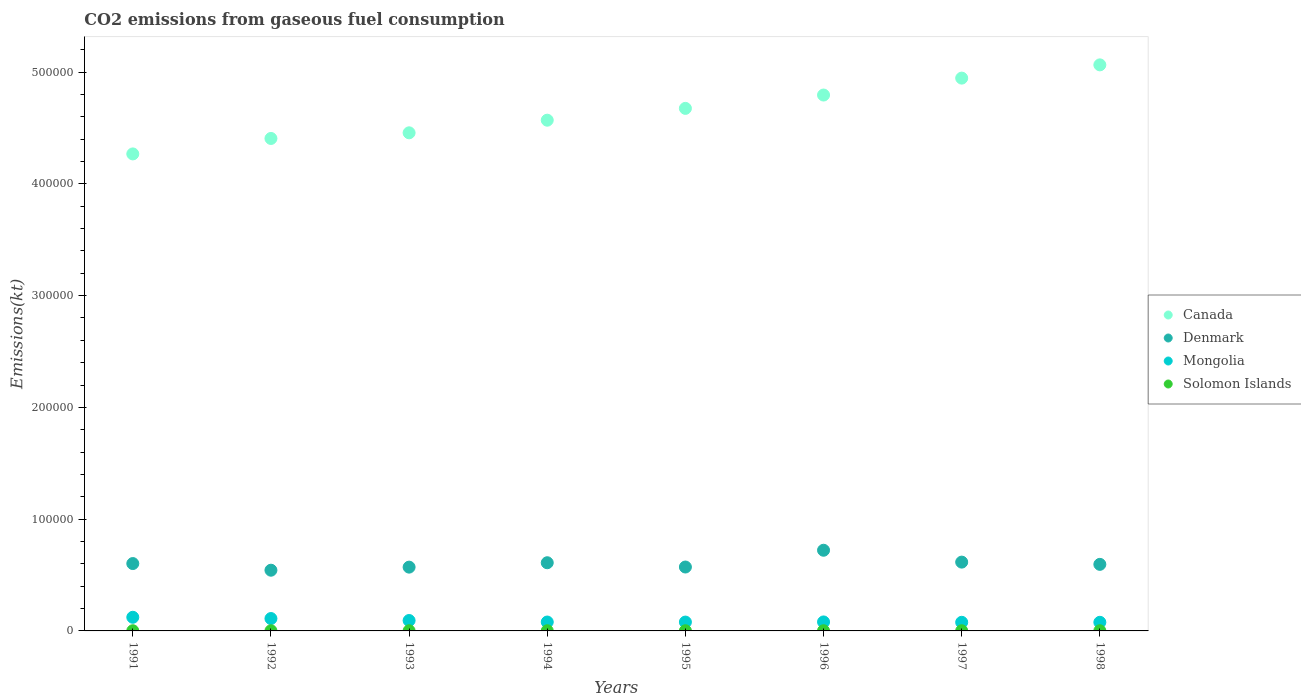What is the amount of CO2 emitted in Denmark in 1998?
Give a very brief answer. 5.96e+04. Across all years, what is the maximum amount of CO2 emitted in Solomon Islands?
Provide a short and direct response. 161.35. Across all years, what is the minimum amount of CO2 emitted in Canada?
Offer a terse response. 4.27e+05. In which year was the amount of CO2 emitted in Mongolia maximum?
Give a very brief answer. 1991. In which year was the amount of CO2 emitted in Solomon Islands minimum?
Your response must be concise. 1994. What is the total amount of CO2 emitted in Mongolia in the graph?
Ensure brevity in your answer.  7.19e+04. What is the difference between the amount of CO2 emitted in Canada in 1995 and that in 1998?
Keep it short and to the point. -3.89e+04. What is the difference between the amount of CO2 emitted in Denmark in 1998 and the amount of CO2 emitted in Mongolia in 1994?
Your response must be concise. 5.16e+04. What is the average amount of CO2 emitted in Denmark per year?
Provide a succinct answer. 6.04e+04. In the year 1997, what is the difference between the amount of CO2 emitted in Denmark and amount of CO2 emitted in Solomon Islands?
Your answer should be compact. 6.14e+04. In how many years, is the amount of CO2 emitted in Mongolia greater than 460000 kt?
Give a very brief answer. 0. What is the ratio of the amount of CO2 emitted in Canada in 1996 to that in 1997?
Your answer should be very brief. 0.97. Is the difference between the amount of CO2 emitted in Denmark in 1992 and 1996 greater than the difference between the amount of CO2 emitted in Solomon Islands in 1992 and 1996?
Offer a terse response. No. What is the difference between the highest and the lowest amount of CO2 emitted in Solomon Islands?
Your response must be concise. 7.33. In how many years, is the amount of CO2 emitted in Denmark greater than the average amount of CO2 emitted in Denmark taken over all years?
Offer a very short reply. 3. Is it the case that in every year, the sum of the amount of CO2 emitted in Denmark and amount of CO2 emitted in Solomon Islands  is greater than the sum of amount of CO2 emitted in Canada and amount of CO2 emitted in Mongolia?
Ensure brevity in your answer.  Yes. Is the amount of CO2 emitted in Denmark strictly greater than the amount of CO2 emitted in Canada over the years?
Provide a succinct answer. No. Is the amount of CO2 emitted in Canada strictly less than the amount of CO2 emitted in Denmark over the years?
Your answer should be very brief. No. How many dotlines are there?
Give a very brief answer. 4. Does the graph contain grids?
Make the answer very short. No. Where does the legend appear in the graph?
Ensure brevity in your answer.  Center right. How many legend labels are there?
Ensure brevity in your answer.  4. What is the title of the graph?
Offer a terse response. CO2 emissions from gaseous fuel consumption. Does "Czech Republic" appear as one of the legend labels in the graph?
Ensure brevity in your answer.  No. What is the label or title of the X-axis?
Your response must be concise. Years. What is the label or title of the Y-axis?
Provide a succinct answer. Emissions(kt). What is the Emissions(kt) of Canada in 1991?
Give a very brief answer. 4.27e+05. What is the Emissions(kt) in Denmark in 1991?
Provide a short and direct response. 6.03e+04. What is the Emissions(kt) of Mongolia in 1991?
Ensure brevity in your answer.  1.22e+04. What is the Emissions(kt) of Solomon Islands in 1991?
Offer a very short reply. 161.35. What is the Emissions(kt) of Canada in 1992?
Provide a succinct answer. 4.41e+05. What is the Emissions(kt) in Denmark in 1992?
Offer a very short reply. 5.43e+04. What is the Emissions(kt) in Mongolia in 1992?
Offer a very short reply. 1.11e+04. What is the Emissions(kt) in Solomon Islands in 1992?
Your answer should be very brief. 161.35. What is the Emissions(kt) in Canada in 1993?
Give a very brief answer. 4.46e+05. What is the Emissions(kt) of Denmark in 1993?
Make the answer very short. 5.71e+04. What is the Emissions(kt) of Mongolia in 1993?
Make the answer very short. 9314.18. What is the Emissions(kt) in Solomon Islands in 1993?
Give a very brief answer. 157.68. What is the Emissions(kt) in Canada in 1994?
Offer a very short reply. 4.57e+05. What is the Emissions(kt) of Denmark in 1994?
Ensure brevity in your answer.  6.10e+04. What is the Emissions(kt) of Mongolia in 1994?
Keep it short and to the point. 7961.06. What is the Emissions(kt) in Solomon Islands in 1994?
Ensure brevity in your answer.  154.01. What is the Emissions(kt) in Canada in 1995?
Your answer should be compact. 4.68e+05. What is the Emissions(kt) of Denmark in 1995?
Make the answer very short. 5.72e+04. What is the Emissions(kt) in Mongolia in 1995?
Offer a very short reply. 7924.39. What is the Emissions(kt) of Solomon Islands in 1995?
Ensure brevity in your answer.  161.35. What is the Emissions(kt) in Canada in 1996?
Keep it short and to the point. 4.79e+05. What is the Emissions(kt) in Denmark in 1996?
Your response must be concise. 7.22e+04. What is the Emissions(kt) in Mongolia in 1996?
Your response must be concise. 8041.73. What is the Emissions(kt) of Solomon Islands in 1996?
Give a very brief answer. 161.35. What is the Emissions(kt) of Canada in 1997?
Provide a short and direct response. 4.95e+05. What is the Emissions(kt) in Denmark in 1997?
Your answer should be very brief. 6.16e+04. What is the Emissions(kt) of Mongolia in 1997?
Ensure brevity in your answer.  7711.7. What is the Emissions(kt) of Solomon Islands in 1997?
Your answer should be very brief. 161.35. What is the Emissions(kt) of Canada in 1998?
Offer a terse response. 5.06e+05. What is the Emissions(kt) of Denmark in 1998?
Your answer should be compact. 5.96e+04. What is the Emissions(kt) of Mongolia in 1998?
Offer a terse response. 7708.03. What is the Emissions(kt) of Solomon Islands in 1998?
Offer a very short reply. 161.35. Across all years, what is the maximum Emissions(kt) of Canada?
Make the answer very short. 5.06e+05. Across all years, what is the maximum Emissions(kt) in Denmark?
Provide a short and direct response. 7.22e+04. Across all years, what is the maximum Emissions(kt) of Mongolia?
Offer a terse response. 1.22e+04. Across all years, what is the maximum Emissions(kt) in Solomon Islands?
Offer a very short reply. 161.35. Across all years, what is the minimum Emissions(kt) of Canada?
Ensure brevity in your answer.  4.27e+05. Across all years, what is the minimum Emissions(kt) in Denmark?
Your response must be concise. 5.43e+04. Across all years, what is the minimum Emissions(kt) of Mongolia?
Provide a short and direct response. 7708.03. Across all years, what is the minimum Emissions(kt) of Solomon Islands?
Your response must be concise. 154.01. What is the total Emissions(kt) of Canada in the graph?
Your answer should be compact. 3.72e+06. What is the total Emissions(kt) in Denmark in the graph?
Keep it short and to the point. 4.83e+05. What is the total Emissions(kt) of Mongolia in the graph?
Your answer should be very brief. 7.19e+04. What is the total Emissions(kt) in Solomon Islands in the graph?
Keep it short and to the point. 1279.78. What is the difference between the Emissions(kt) in Canada in 1991 and that in 1992?
Provide a succinct answer. -1.38e+04. What is the difference between the Emissions(kt) in Denmark in 1991 and that in 1992?
Give a very brief answer. 5947.87. What is the difference between the Emissions(kt) of Mongolia in 1991 and that in 1992?
Provide a succinct answer. 1129.44. What is the difference between the Emissions(kt) in Canada in 1991 and that in 1993?
Keep it short and to the point. -1.89e+04. What is the difference between the Emissions(kt) of Denmark in 1991 and that in 1993?
Keep it short and to the point. 3204.96. What is the difference between the Emissions(kt) in Mongolia in 1991 and that in 1993?
Provide a short and direct response. 2893.26. What is the difference between the Emissions(kt) of Solomon Islands in 1991 and that in 1993?
Your answer should be compact. 3.67. What is the difference between the Emissions(kt) of Canada in 1991 and that in 1994?
Provide a short and direct response. -3.02e+04. What is the difference between the Emissions(kt) of Denmark in 1991 and that in 1994?
Provide a short and direct response. -729.73. What is the difference between the Emissions(kt) in Mongolia in 1991 and that in 1994?
Ensure brevity in your answer.  4246.39. What is the difference between the Emissions(kt) of Solomon Islands in 1991 and that in 1994?
Your answer should be compact. 7.33. What is the difference between the Emissions(kt) in Canada in 1991 and that in 1995?
Your answer should be compact. -4.07e+04. What is the difference between the Emissions(kt) in Denmark in 1991 and that in 1995?
Provide a succinct answer. 3098.61. What is the difference between the Emissions(kt) of Mongolia in 1991 and that in 1995?
Your answer should be very brief. 4283.06. What is the difference between the Emissions(kt) in Solomon Islands in 1991 and that in 1995?
Your response must be concise. 0. What is the difference between the Emissions(kt) in Canada in 1991 and that in 1996?
Your answer should be compact. -5.27e+04. What is the difference between the Emissions(kt) of Denmark in 1991 and that in 1996?
Make the answer very short. -1.19e+04. What is the difference between the Emissions(kt) of Mongolia in 1991 and that in 1996?
Offer a very short reply. 4165.71. What is the difference between the Emissions(kt) in Solomon Islands in 1991 and that in 1996?
Provide a short and direct response. 0. What is the difference between the Emissions(kt) of Canada in 1991 and that in 1997?
Keep it short and to the point. -6.78e+04. What is the difference between the Emissions(kt) of Denmark in 1991 and that in 1997?
Your answer should be compact. -1287.12. What is the difference between the Emissions(kt) of Mongolia in 1991 and that in 1997?
Offer a very short reply. 4495.74. What is the difference between the Emissions(kt) of Solomon Islands in 1991 and that in 1997?
Your response must be concise. 0. What is the difference between the Emissions(kt) in Canada in 1991 and that in 1998?
Provide a succinct answer. -7.97e+04. What is the difference between the Emissions(kt) in Denmark in 1991 and that in 1998?
Offer a terse response. 718.73. What is the difference between the Emissions(kt) in Mongolia in 1991 and that in 1998?
Make the answer very short. 4499.41. What is the difference between the Emissions(kt) in Canada in 1992 and that in 1993?
Your answer should be compact. -5056.79. What is the difference between the Emissions(kt) of Denmark in 1992 and that in 1993?
Your answer should be very brief. -2742.92. What is the difference between the Emissions(kt) in Mongolia in 1992 and that in 1993?
Offer a very short reply. 1763.83. What is the difference between the Emissions(kt) of Solomon Islands in 1992 and that in 1993?
Give a very brief answer. 3.67. What is the difference between the Emissions(kt) of Canada in 1992 and that in 1994?
Your answer should be very brief. -1.63e+04. What is the difference between the Emissions(kt) in Denmark in 1992 and that in 1994?
Your answer should be compact. -6677.61. What is the difference between the Emissions(kt) in Mongolia in 1992 and that in 1994?
Make the answer very short. 3116.95. What is the difference between the Emissions(kt) in Solomon Islands in 1992 and that in 1994?
Ensure brevity in your answer.  7.33. What is the difference between the Emissions(kt) of Canada in 1992 and that in 1995?
Offer a very short reply. -2.69e+04. What is the difference between the Emissions(kt) of Denmark in 1992 and that in 1995?
Offer a terse response. -2849.26. What is the difference between the Emissions(kt) in Mongolia in 1992 and that in 1995?
Make the answer very short. 3153.62. What is the difference between the Emissions(kt) in Canada in 1992 and that in 1996?
Your answer should be very brief. -3.89e+04. What is the difference between the Emissions(kt) of Denmark in 1992 and that in 1996?
Your answer should be very brief. -1.79e+04. What is the difference between the Emissions(kt) of Mongolia in 1992 and that in 1996?
Offer a terse response. 3036.28. What is the difference between the Emissions(kt) of Canada in 1992 and that in 1997?
Provide a short and direct response. -5.40e+04. What is the difference between the Emissions(kt) of Denmark in 1992 and that in 1997?
Your response must be concise. -7234.99. What is the difference between the Emissions(kt) of Mongolia in 1992 and that in 1997?
Your response must be concise. 3366.31. What is the difference between the Emissions(kt) in Solomon Islands in 1992 and that in 1997?
Offer a terse response. 0. What is the difference between the Emissions(kt) of Canada in 1992 and that in 1998?
Make the answer very short. -6.58e+04. What is the difference between the Emissions(kt) in Denmark in 1992 and that in 1998?
Offer a very short reply. -5229.14. What is the difference between the Emissions(kt) of Mongolia in 1992 and that in 1998?
Make the answer very short. 3369.97. What is the difference between the Emissions(kt) of Canada in 1993 and that in 1994?
Keep it short and to the point. -1.13e+04. What is the difference between the Emissions(kt) in Denmark in 1993 and that in 1994?
Provide a short and direct response. -3934.69. What is the difference between the Emissions(kt) in Mongolia in 1993 and that in 1994?
Keep it short and to the point. 1353.12. What is the difference between the Emissions(kt) of Solomon Islands in 1993 and that in 1994?
Your answer should be very brief. 3.67. What is the difference between the Emissions(kt) of Canada in 1993 and that in 1995?
Your answer should be very brief. -2.19e+04. What is the difference between the Emissions(kt) in Denmark in 1993 and that in 1995?
Your answer should be very brief. -106.34. What is the difference between the Emissions(kt) of Mongolia in 1993 and that in 1995?
Provide a succinct answer. 1389.79. What is the difference between the Emissions(kt) in Solomon Islands in 1993 and that in 1995?
Give a very brief answer. -3.67. What is the difference between the Emissions(kt) of Canada in 1993 and that in 1996?
Offer a very short reply. -3.38e+04. What is the difference between the Emissions(kt) in Denmark in 1993 and that in 1996?
Your answer should be compact. -1.51e+04. What is the difference between the Emissions(kt) of Mongolia in 1993 and that in 1996?
Keep it short and to the point. 1272.45. What is the difference between the Emissions(kt) of Solomon Islands in 1993 and that in 1996?
Give a very brief answer. -3.67. What is the difference between the Emissions(kt) in Canada in 1993 and that in 1997?
Ensure brevity in your answer.  -4.89e+04. What is the difference between the Emissions(kt) of Denmark in 1993 and that in 1997?
Offer a terse response. -4492.07. What is the difference between the Emissions(kt) in Mongolia in 1993 and that in 1997?
Offer a very short reply. 1602.48. What is the difference between the Emissions(kt) of Solomon Islands in 1993 and that in 1997?
Provide a succinct answer. -3.67. What is the difference between the Emissions(kt) in Canada in 1993 and that in 1998?
Your answer should be compact. -6.08e+04. What is the difference between the Emissions(kt) in Denmark in 1993 and that in 1998?
Provide a short and direct response. -2486.23. What is the difference between the Emissions(kt) of Mongolia in 1993 and that in 1998?
Give a very brief answer. 1606.15. What is the difference between the Emissions(kt) of Solomon Islands in 1993 and that in 1998?
Provide a short and direct response. -3.67. What is the difference between the Emissions(kt) of Canada in 1994 and that in 1995?
Your response must be concise. -1.06e+04. What is the difference between the Emissions(kt) in Denmark in 1994 and that in 1995?
Your answer should be very brief. 3828.35. What is the difference between the Emissions(kt) of Mongolia in 1994 and that in 1995?
Your answer should be very brief. 36.67. What is the difference between the Emissions(kt) in Solomon Islands in 1994 and that in 1995?
Provide a short and direct response. -7.33. What is the difference between the Emissions(kt) of Canada in 1994 and that in 1996?
Keep it short and to the point. -2.25e+04. What is the difference between the Emissions(kt) in Denmark in 1994 and that in 1996?
Make the answer very short. -1.12e+04. What is the difference between the Emissions(kt) in Mongolia in 1994 and that in 1996?
Provide a succinct answer. -80.67. What is the difference between the Emissions(kt) of Solomon Islands in 1994 and that in 1996?
Provide a short and direct response. -7.33. What is the difference between the Emissions(kt) in Canada in 1994 and that in 1997?
Give a very brief answer. -3.76e+04. What is the difference between the Emissions(kt) in Denmark in 1994 and that in 1997?
Ensure brevity in your answer.  -557.38. What is the difference between the Emissions(kt) of Mongolia in 1994 and that in 1997?
Your answer should be very brief. 249.36. What is the difference between the Emissions(kt) of Solomon Islands in 1994 and that in 1997?
Ensure brevity in your answer.  -7.33. What is the difference between the Emissions(kt) of Canada in 1994 and that in 1998?
Your response must be concise. -4.95e+04. What is the difference between the Emissions(kt) of Denmark in 1994 and that in 1998?
Give a very brief answer. 1448.46. What is the difference between the Emissions(kt) of Mongolia in 1994 and that in 1998?
Make the answer very short. 253.02. What is the difference between the Emissions(kt) of Solomon Islands in 1994 and that in 1998?
Give a very brief answer. -7.33. What is the difference between the Emissions(kt) of Canada in 1995 and that in 1996?
Make the answer very short. -1.19e+04. What is the difference between the Emissions(kt) in Denmark in 1995 and that in 1996?
Ensure brevity in your answer.  -1.50e+04. What is the difference between the Emissions(kt) in Mongolia in 1995 and that in 1996?
Provide a short and direct response. -117.34. What is the difference between the Emissions(kt) in Solomon Islands in 1995 and that in 1996?
Provide a succinct answer. 0. What is the difference between the Emissions(kt) of Canada in 1995 and that in 1997?
Offer a terse response. -2.71e+04. What is the difference between the Emissions(kt) of Denmark in 1995 and that in 1997?
Provide a short and direct response. -4385.73. What is the difference between the Emissions(kt) of Mongolia in 1995 and that in 1997?
Your answer should be very brief. 212.69. What is the difference between the Emissions(kt) in Canada in 1995 and that in 1998?
Provide a short and direct response. -3.89e+04. What is the difference between the Emissions(kt) in Denmark in 1995 and that in 1998?
Provide a succinct answer. -2379.88. What is the difference between the Emissions(kt) in Mongolia in 1995 and that in 1998?
Keep it short and to the point. 216.35. What is the difference between the Emissions(kt) of Canada in 1996 and that in 1997?
Your response must be concise. -1.51e+04. What is the difference between the Emissions(kt) of Denmark in 1996 and that in 1997?
Ensure brevity in your answer.  1.06e+04. What is the difference between the Emissions(kt) of Mongolia in 1996 and that in 1997?
Provide a short and direct response. 330.03. What is the difference between the Emissions(kt) of Canada in 1996 and that in 1998?
Your answer should be compact. -2.70e+04. What is the difference between the Emissions(kt) of Denmark in 1996 and that in 1998?
Ensure brevity in your answer.  1.26e+04. What is the difference between the Emissions(kt) in Mongolia in 1996 and that in 1998?
Ensure brevity in your answer.  333.7. What is the difference between the Emissions(kt) in Solomon Islands in 1996 and that in 1998?
Offer a very short reply. 0. What is the difference between the Emissions(kt) of Canada in 1997 and that in 1998?
Keep it short and to the point. -1.19e+04. What is the difference between the Emissions(kt) in Denmark in 1997 and that in 1998?
Provide a short and direct response. 2005.85. What is the difference between the Emissions(kt) of Mongolia in 1997 and that in 1998?
Keep it short and to the point. 3.67. What is the difference between the Emissions(kt) in Solomon Islands in 1997 and that in 1998?
Offer a very short reply. 0. What is the difference between the Emissions(kt) in Canada in 1991 and the Emissions(kt) in Denmark in 1992?
Ensure brevity in your answer.  3.72e+05. What is the difference between the Emissions(kt) in Canada in 1991 and the Emissions(kt) in Mongolia in 1992?
Give a very brief answer. 4.16e+05. What is the difference between the Emissions(kt) of Canada in 1991 and the Emissions(kt) of Solomon Islands in 1992?
Your answer should be compact. 4.27e+05. What is the difference between the Emissions(kt) in Denmark in 1991 and the Emissions(kt) in Mongolia in 1992?
Provide a succinct answer. 4.92e+04. What is the difference between the Emissions(kt) in Denmark in 1991 and the Emissions(kt) in Solomon Islands in 1992?
Your answer should be compact. 6.01e+04. What is the difference between the Emissions(kt) of Mongolia in 1991 and the Emissions(kt) of Solomon Islands in 1992?
Provide a succinct answer. 1.20e+04. What is the difference between the Emissions(kt) of Canada in 1991 and the Emissions(kt) of Denmark in 1993?
Ensure brevity in your answer.  3.70e+05. What is the difference between the Emissions(kt) of Canada in 1991 and the Emissions(kt) of Mongolia in 1993?
Your response must be concise. 4.17e+05. What is the difference between the Emissions(kt) in Canada in 1991 and the Emissions(kt) in Solomon Islands in 1993?
Provide a succinct answer. 4.27e+05. What is the difference between the Emissions(kt) of Denmark in 1991 and the Emissions(kt) of Mongolia in 1993?
Offer a terse response. 5.10e+04. What is the difference between the Emissions(kt) of Denmark in 1991 and the Emissions(kt) of Solomon Islands in 1993?
Your answer should be very brief. 6.01e+04. What is the difference between the Emissions(kt) of Mongolia in 1991 and the Emissions(kt) of Solomon Islands in 1993?
Offer a very short reply. 1.20e+04. What is the difference between the Emissions(kt) in Canada in 1991 and the Emissions(kt) in Denmark in 1994?
Your answer should be compact. 3.66e+05. What is the difference between the Emissions(kt) of Canada in 1991 and the Emissions(kt) of Mongolia in 1994?
Offer a terse response. 4.19e+05. What is the difference between the Emissions(kt) in Canada in 1991 and the Emissions(kt) in Solomon Islands in 1994?
Offer a very short reply. 4.27e+05. What is the difference between the Emissions(kt) of Denmark in 1991 and the Emissions(kt) of Mongolia in 1994?
Your answer should be very brief. 5.23e+04. What is the difference between the Emissions(kt) of Denmark in 1991 and the Emissions(kt) of Solomon Islands in 1994?
Your response must be concise. 6.01e+04. What is the difference between the Emissions(kt) in Mongolia in 1991 and the Emissions(kt) in Solomon Islands in 1994?
Provide a short and direct response. 1.21e+04. What is the difference between the Emissions(kt) in Canada in 1991 and the Emissions(kt) in Denmark in 1995?
Offer a terse response. 3.70e+05. What is the difference between the Emissions(kt) of Canada in 1991 and the Emissions(kt) of Mongolia in 1995?
Your answer should be compact. 4.19e+05. What is the difference between the Emissions(kt) in Canada in 1991 and the Emissions(kt) in Solomon Islands in 1995?
Give a very brief answer. 4.27e+05. What is the difference between the Emissions(kt) in Denmark in 1991 and the Emissions(kt) in Mongolia in 1995?
Your response must be concise. 5.23e+04. What is the difference between the Emissions(kt) of Denmark in 1991 and the Emissions(kt) of Solomon Islands in 1995?
Provide a short and direct response. 6.01e+04. What is the difference between the Emissions(kt) of Mongolia in 1991 and the Emissions(kt) of Solomon Islands in 1995?
Provide a succinct answer. 1.20e+04. What is the difference between the Emissions(kt) in Canada in 1991 and the Emissions(kt) in Denmark in 1996?
Offer a very short reply. 3.55e+05. What is the difference between the Emissions(kt) in Canada in 1991 and the Emissions(kt) in Mongolia in 1996?
Make the answer very short. 4.19e+05. What is the difference between the Emissions(kt) of Canada in 1991 and the Emissions(kt) of Solomon Islands in 1996?
Keep it short and to the point. 4.27e+05. What is the difference between the Emissions(kt) in Denmark in 1991 and the Emissions(kt) in Mongolia in 1996?
Make the answer very short. 5.22e+04. What is the difference between the Emissions(kt) in Denmark in 1991 and the Emissions(kt) in Solomon Islands in 1996?
Keep it short and to the point. 6.01e+04. What is the difference between the Emissions(kt) of Mongolia in 1991 and the Emissions(kt) of Solomon Islands in 1996?
Offer a very short reply. 1.20e+04. What is the difference between the Emissions(kt) in Canada in 1991 and the Emissions(kt) in Denmark in 1997?
Your response must be concise. 3.65e+05. What is the difference between the Emissions(kt) in Canada in 1991 and the Emissions(kt) in Mongolia in 1997?
Offer a very short reply. 4.19e+05. What is the difference between the Emissions(kt) in Canada in 1991 and the Emissions(kt) in Solomon Islands in 1997?
Your response must be concise. 4.27e+05. What is the difference between the Emissions(kt) in Denmark in 1991 and the Emissions(kt) in Mongolia in 1997?
Offer a terse response. 5.26e+04. What is the difference between the Emissions(kt) of Denmark in 1991 and the Emissions(kt) of Solomon Islands in 1997?
Ensure brevity in your answer.  6.01e+04. What is the difference between the Emissions(kt) of Mongolia in 1991 and the Emissions(kt) of Solomon Islands in 1997?
Ensure brevity in your answer.  1.20e+04. What is the difference between the Emissions(kt) of Canada in 1991 and the Emissions(kt) of Denmark in 1998?
Make the answer very short. 3.67e+05. What is the difference between the Emissions(kt) of Canada in 1991 and the Emissions(kt) of Mongolia in 1998?
Your answer should be very brief. 4.19e+05. What is the difference between the Emissions(kt) of Canada in 1991 and the Emissions(kt) of Solomon Islands in 1998?
Provide a short and direct response. 4.27e+05. What is the difference between the Emissions(kt) of Denmark in 1991 and the Emissions(kt) of Mongolia in 1998?
Ensure brevity in your answer.  5.26e+04. What is the difference between the Emissions(kt) of Denmark in 1991 and the Emissions(kt) of Solomon Islands in 1998?
Ensure brevity in your answer.  6.01e+04. What is the difference between the Emissions(kt) in Mongolia in 1991 and the Emissions(kt) in Solomon Islands in 1998?
Provide a succinct answer. 1.20e+04. What is the difference between the Emissions(kt) of Canada in 1992 and the Emissions(kt) of Denmark in 1993?
Ensure brevity in your answer.  3.84e+05. What is the difference between the Emissions(kt) in Canada in 1992 and the Emissions(kt) in Mongolia in 1993?
Offer a terse response. 4.31e+05. What is the difference between the Emissions(kt) of Canada in 1992 and the Emissions(kt) of Solomon Islands in 1993?
Provide a succinct answer. 4.40e+05. What is the difference between the Emissions(kt) in Denmark in 1992 and the Emissions(kt) in Mongolia in 1993?
Give a very brief answer. 4.50e+04. What is the difference between the Emissions(kt) of Denmark in 1992 and the Emissions(kt) of Solomon Islands in 1993?
Make the answer very short. 5.42e+04. What is the difference between the Emissions(kt) in Mongolia in 1992 and the Emissions(kt) in Solomon Islands in 1993?
Provide a succinct answer. 1.09e+04. What is the difference between the Emissions(kt) in Canada in 1992 and the Emissions(kt) in Denmark in 1994?
Your answer should be compact. 3.80e+05. What is the difference between the Emissions(kt) of Canada in 1992 and the Emissions(kt) of Mongolia in 1994?
Your answer should be compact. 4.33e+05. What is the difference between the Emissions(kt) in Canada in 1992 and the Emissions(kt) in Solomon Islands in 1994?
Provide a succinct answer. 4.40e+05. What is the difference between the Emissions(kt) of Denmark in 1992 and the Emissions(kt) of Mongolia in 1994?
Provide a short and direct response. 4.64e+04. What is the difference between the Emissions(kt) in Denmark in 1992 and the Emissions(kt) in Solomon Islands in 1994?
Give a very brief answer. 5.42e+04. What is the difference between the Emissions(kt) in Mongolia in 1992 and the Emissions(kt) in Solomon Islands in 1994?
Provide a short and direct response. 1.09e+04. What is the difference between the Emissions(kt) of Canada in 1992 and the Emissions(kt) of Denmark in 1995?
Your answer should be very brief. 3.83e+05. What is the difference between the Emissions(kt) in Canada in 1992 and the Emissions(kt) in Mongolia in 1995?
Your answer should be compact. 4.33e+05. What is the difference between the Emissions(kt) of Canada in 1992 and the Emissions(kt) of Solomon Islands in 1995?
Your answer should be very brief. 4.40e+05. What is the difference between the Emissions(kt) of Denmark in 1992 and the Emissions(kt) of Mongolia in 1995?
Provide a succinct answer. 4.64e+04. What is the difference between the Emissions(kt) of Denmark in 1992 and the Emissions(kt) of Solomon Islands in 1995?
Your answer should be very brief. 5.42e+04. What is the difference between the Emissions(kt) of Mongolia in 1992 and the Emissions(kt) of Solomon Islands in 1995?
Give a very brief answer. 1.09e+04. What is the difference between the Emissions(kt) of Canada in 1992 and the Emissions(kt) of Denmark in 1996?
Offer a terse response. 3.68e+05. What is the difference between the Emissions(kt) in Canada in 1992 and the Emissions(kt) in Mongolia in 1996?
Your answer should be very brief. 4.33e+05. What is the difference between the Emissions(kt) in Canada in 1992 and the Emissions(kt) in Solomon Islands in 1996?
Offer a very short reply. 4.40e+05. What is the difference between the Emissions(kt) in Denmark in 1992 and the Emissions(kt) in Mongolia in 1996?
Offer a very short reply. 4.63e+04. What is the difference between the Emissions(kt) of Denmark in 1992 and the Emissions(kt) of Solomon Islands in 1996?
Keep it short and to the point. 5.42e+04. What is the difference between the Emissions(kt) of Mongolia in 1992 and the Emissions(kt) of Solomon Islands in 1996?
Ensure brevity in your answer.  1.09e+04. What is the difference between the Emissions(kt) in Canada in 1992 and the Emissions(kt) in Denmark in 1997?
Give a very brief answer. 3.79e+05. What is the difference between the Emissions(kt) in Canada in 1992 and the Emissions(kt) in Mongolia in 1997?
Offer a terse response. 4.33e+05. What is the difference between the Emissions(kt) of Canada in 1992 and the Emissions(kt) of Solomon Islands in 1997?
Ensure brevity in your answer.  4.40e+05. What is the difference between the Emissions(kt) of Denmark in 1992 and the Emissions(kt) of Mongolia in 1997?
Your answer should be very brief. 4.66e+04. What is the difference between the Emissions(kt) in Denmark in 1992 and the Emissions(kt) in Solomon Islands in 1997?
Offer a very short reply. 5.42e+04. What is the difference between the Emissions(kt) of Mongolia in 1992 and the Emissions(kt) of Solomon Islands in 1997?
Offer a terse response. 1.09e+04. What is the difference between the Emissions(kt) of Canada in 1992 and the Emissions(kt) of Denmark in 1998?
Keep it short and to the point. 3.81e+05. What is the difference between the Emissions(kt) of Canada in 1992 and the Emissions(kt) of Mongolia in 1998?
Your answer should be compact. 4.33e+05. What is the difference between the Emissions(kt) in Canada in 1992 and the Emissions(kt) in Solomon Islands in 1998?
Give a very brief answer. 4.40e+05. What is the difference between the Emissions(kt) of Denmark in 1992 and the Emissions(kt) of Mongolia in 1998?
Your answer should be very brief. 4.66e+04. What is the difference between the Emissions(kt) of Denmark in 1992 and the Emissions(kt) of Solomon Islands in 1998?
Keep it short and to the point. 5.42e+04. What is the difference between the Emissions(kt) of Mongolia in 1992 and the Emissions(kt) of Solomon Islands in 1998?
Offer a very short reply. 1.09e+04. What is the difference between the Emissions(kt) of Canada in 1993 and the Emissions(kt) of Denmark in 1994?
Make the answer very short. 3.85e+05. What is the difference between the Emissions(kt) in Canada in 1993 and the Emissions(kt) in Mongolia in 1994?
Make the answer very short. 4.38e+05. What is the difference between the Emissions(kt) in Canada in 1993 and the Emissions(kt) in Solomon Islands in 1994?
Ensure brevity in your answer.  4.46e+05. What is the difference between the Emissions(kt) of Denmark in 1993 and the Emissions(kt) of Mongolia in 1994?
Offer a terse response. 4.91e+04. What is the difference between the Emissions(kt) of Denmark in 1993 and the Emissions(kt) of Solomon Islands in 1994?
Provide a short and direct response. 5.69e+04. What is the difference between the Emissions(kt) in Mongolia in 1993 and the Emissions(kt) in Solomon Islands in 1994?
Provide a short and direct response. 9160.17. What is the difference between the Emissions(kt) in Canada in 1993 and the Emissions(kt) in Denmark in 1995?
Give a very brief answer. 3.88e+05. What is the difference between the Emissions(kt) in Canada in 1993 and the Emissions(kt) in Mongolia in 1995?
Your response must be concise. 4.38e+05. What is the difference between the Emissions(kt) in Canada in 1993 and the Emissions(kt) in Solomon Islands in 1995?
Offer a terse response. 4.46e+05. What is the difference between the Emissions(kt) of Denmark in 1993 and the Emissions(kt) of Mongolia in 1995?
Give a very brief answer. 4.91e+04. What is the difference between the Emissions(kt) of Denmark in 1993 and the Emissions(kt) of Solomon Islands in 1995?
Offer a very short reply. 5.69e+04. What is the difference between the Emissions(kt) in Mongolia in 1993 and the Emissions(kt) in Solomon Islands in 1995?
Offer a very short reply. 9152.83. What is the difference between the Emissions(kt) of Canada in 1993 and the Emissions(kt) of Denmark in 1996?
Keep it short and to the point. 3.73e+05. What is the difference between the Emissions(kt) of Canada in 1993 and the Emissions(kt) of Mongolia in 1996?
Your answer should be compact. 4.38e+05. What is the difference between the Emissions(kt) of Canada in 1993 and the Emissions(kt) of Solomon Islands in 1996?
Make the answer very short. 4.46e+05. What is the difference between the Emissions(kt) of Denmark in 1993 and the Emissions(kt) of Mongolia in 1996?
Your answer should be compact. 4.90e+04. What is the difference between the Emissions(kt) of Denmark in 1993 and the Emissions(kt) of Solomon Islands in 1996?
Provide a succinct answer. 5.69e+04. What is the difference between the Emissions(kt) in Mongolia in 1993 and the Emissions(kt) in Solomon Islands in 1996?
Provide a succinct answer. 9152.83. What is the difference between the Emissions(kt) in Canada in 1993 and the Emissions(kt) in Denmark in 1997?
Your answer should be compact. 3.84e+05. What is the difference between the Emissions(kt) in Canada in 1993 and the Emissions(kt) in Mongolia in 1997?
Offer a very short reply. 4.38e+05. What is the difference between the Emissions(kt) in Canada in 1993 and the Emissions(kt) in Solomon Islands in 1997?
Give a very brief answer. 4.46e+05. What is the difference between the Emissions(kt) of Denmark in 1993 and the Emissions(kt) of Mongolia in 1997?
Give a very brief answer. 4.94e+04. What is the difference between the Emissions(kt) of Denmark in 1993 and the Emissions(kt) of Solomon Islands in 1997?
Give a very brief answer. 5.69e+04. What is the difference between the Emissions(kt) of Mongolia in 1993 and the Emissions(kt) of Solomon Islands in 1997?
Keep it short and to the point. 9152.83. What is the difference between the Emissions(kt) in Canada in 1993 and the Emissions(kt) in Denmark in 1998?
Offer a very short reply. 3.86e+05. What is the difference between the Emissions(kt) in Canada in 1993 and the Emissions(kt) in Mongolia in 1998?
Your answer should be very brief. 4.38e+05. What is the difference between the Emissions(kt) of Canada in 1993 and the Emissions(kt) of Solomon Islands in 1998?
Give a very brief answer. 4.46e+05. What is the difference between the Emissions(kt) of Denmark in 1993 and the Emissions(kt) of Mongolia in 1998?
Offer a very short reply. 4.94e+04. What is the difference between the Emissions(kt) in Denmark in 1993 and the Emissions(kt) in Solomon Islands in 1998?
Give a very brief answer. 5.69e+04. What is the difference between the Emissions(kt) of Mongolia in 1993 and the Emissions(kt) of Solomon Islands in 1998?
Offer a terse response. 9152.83. What is the difference between the Emissions(kt) of Canada in 1994 and the Emissions(kt) of Denmark in 1995?
Offer a terse response. 4.00e+05. What is the difference between the Emissions(kt) in Canada in 1994 and the Emissions(kt) in Mongolia in 1995?
Your response must be concise. 4.49e+05. What is the difference between the Emissions(kt) of Canada in 1994 and the Emissions(kt) of Solomon Islands in 1995?
Your answer should be compact. 4.57e+05. What is the difference between the Emissions(kt) in Denmark in 1994 and the Emissions(kt) in Mongolia in 1995?
Your response must be concise. 5.31e+04. What is the difference between the Emissions(kt) in Denmark in 1994 and the Emissions(kt) in Solomon Islands in 1995?
Your answer should be compact. 6.08e+04. What is the difference between the Emissions(kt) in Mongolia in 1994 and the Emissions(kt) in Solomon Islands in 1995?
Your answer should be very brief. 7799.71. What is the difference between the Emissions(kt) in Canada in 1994 and the Emissions(kt) in Denmark in 1996?
Offer a very short reply. 3.85e+05. What is the difference between the Emissions(kt) of Canada in 1994 and the Emissions(kt) of Mongolia in 1996?
Provide a succinct answer. 4.49e+05. What is the difference between the Emissions(kt) in Canada in 1994 and the Emissions(kt) in Solomon Islands in 1996?
Offer a terse response. 4.57e+05. What is the difference between the Emissions(kt) in Denmark in 1994 and the Emissions(kt) in Mongolia in 1996?
Ensure brevity in your answer.  5.30e+04. What is the difference between the Emissions(kt) in Denmark in 1994 and the Emissions(kt) in Solomon Islands in 1996?
Offer a very short reply. 6.08e+04. What is the difference between the Emissions(kt) of Mongolia in 1994 and the Emissions(kt) of Solomon Islands in 1996?
Keep it short and to the point. 7799.71. What is the difference between the Emissions(kt) in Canada in 1994 and the Emissions(kt) in Denmark in 1997?
Provide a short and direct response. 3.95e+05. What is the difference between the Emissions(kt) of Canada in 1994 and the Emissions(kt) of Mongolia in 1997?
Ensure brevity in your answer.  4.49e+05. What is the difference between the Emissions(kt) in Canada in 1994 and the Emissions(kt) in Solomon Islands in 1997?
Keep it short and to the point. 4.57e+05. What is the difference between the Emissions(kt) in Denmark in 1994 and the Emissions(kt) in Mongolia in 1997?
Your response must be concise. 5.33e+04. What is the difference between the Emissions(kt) of Denmark in 1994 and the Emissions(kt) of Solomon Islands in 1997?
Your response must be concise. 6.08e+04. What is the difference between the Emissions(kt) of Mongolia in 1994 and the Emissions(kt) of Solomon Islands in 1997?
Provide a short and direct response. 7799.71. What is the difference between the Emissions(kt) in Canada in 1994 and the Emissions(kt) in Denmark in 1998?
Your response must be concise. 3.97e+05. What is the difference between the Emissions(kt) in Canada in 1994 and the Emissions(kt) in Mongolia in 1998?
Your answer should be compact. 4.49e+05. What is the difference between the Emissions(kt) in Canada in 1994 and the Emissions(kt) in Solomon Islands in 1998?
Your answer should be very brief. 4.57e+05. What is the difference between the Emissions(kt) in Denmark in 1994 and the Emissions(kt) in Mongolia in 1998?
Your response must be concise. 5.33e+04. What is the difference between the Emissions(kt) in Denmark in 1994 and the Emissions(kt) in Solomon Islands in 1998?
Give a very brief answer. 6.08e+04. What is the difference between the Emissions(kt) of Mongolia in 1994 and the Emissions(kt) of Solomon Islands in 1998?
Your answer should be compact. 7799.71. What is the difference between the Emissions(kt) in Canada in 1995 and the Emissions(kt) in Denmark in 1996?
Keep it short and to the point. 3.95e+05. What is the difference between the Emissions(kt) in Canada in 1995 and the Emissions(kt) in Mongolia in 1996?
Offer a terse response. 4.59e+05. What is the difference between the Emissions(kt) in Canada in 1995 and the Emissions(kt) in Solomon Islands in 1996?
Offer a terse response. 4.67e+05. What is the difference between the Emissions(kt) of Denmark in 1995 and the Emissions(kt) of Mongolia in 1996?
Your answer should be compact. 4.91e+04. What is the difference between the Emissions(kt) of Denmark in 1995 and the Emissions(kt) of Solomon Islands in 1996?
Offer a terse response. 5.70e+04. What is the difference between the Emissions(kt) of Mongolia in 1995 and the Emissions(kt) of Solomon Islands in 1996?
Your response must be concise. 7763.04. What is the difference between the Emissions(kt) in Canada in 1995 and the Emissions(kt) in Denmark in 1997?
Offer a very short reply. 4.06e+05. What is the difference between the Emissions(kt) of Canada in 1995 and the Emissions(kt) of Mongolia in 1997?
Your answer should be compact. 4.60e+05. What is the difference between the Emissions(kt) in Canada in 1995 and the Emissions(kt) in Solomon Islands in 1997?
Your answer should be very brief. 4.67e+05. What is the difference between the Emissions(kt) in Denmark in 1995 and the Emissions(kt) in Mongolia in 1997?
Offer a terse response. 4.95e+04. What is the difference between the Emissions(kt) in Denmark in 1995 and the Emissions(kt) in Solomon Islands in 1997?
Keep it short and to the point. 5.70e+04. What is the difference between the Emissions(kt) in Mongolia in 1995 and the Emissions(kt) in Solomon Islands in 1997?
Your response must be concise. 7763.04. What is the difference between the Emissions(kt) of Canada in 1995 and the Emissions(kt) of Denmark in 1998?
Make the answer very short. 4.08e+05. What is the difference between the Emissions(kt) in Canada in 1995 and the Emissions(kt) in Mongolia in 1998?
Your answer should be compact. 4.60e+05. What is the difference between the Emissions(kt) in Canada in 1995 and the Emissions(kt) in Solomon Islands in 1998?
Provide a short and direct response. 4.67e+05. What is the difference between the Emissions(kt) of Denmark in 1995 and the Emissions(kt) of Mongolia in 1998?
Ensure brevity in your answer.  4.95e+04. What is the difference between the Emissions(kt) of Denmark in 1995 and the Emissions(kt) of Solomon Islands in 1998?
Your answer should be very brief. 5.70e+04. What is the difference between the Emissions(kt) of Mongolia in 1995 and the Emissions(kt) of Solomon Islands in 1998?
Offer a terse response. 7763.04. What is the difference between the Emissions(kt) in Canada in 1996 and the Emissions(kt) in Denmark in 1997?
Give a very brief answer. 4.18e+05. What is the difference between the Emissions(kt) in Canada in 1996 and the Emissions(kt) in Mongolia in 1997?
Ensure brevity in your answer.  4.72e+05. What is the difference between the Emissions(kt) of Canada in 1996 and the Emissions(kt) of Solomon Islands in 1997?
Your answer should be very brief. 4.79e+05. What is the difference between the Emissions(kt) of Denmark in 1996 and the Emissions(kt) of Mongolia in 1997?
Make the answer very short. 6.45e+04. What is the difference between the Emissions(kt) in Denmark in 1996 and the Emissions(kt) in Solomon Islands in 1997?
Provide a succinct answer. 7.20e+04. What is the difference between the Emissions(kt) of Mongolia in 1996 and the Emissions(kt) of Solomon Islands in 1997?
Provide a short and direct response. 7880.38. What is the difference between the Emissions(kt) in Canada in 1996 and the Emissions(kt) in Denmark in 1998?
Your answer should be compact. 4.20e+05. What is the difference between the Emissions(kt) in Canada in 1996 and the Emissions(kt) in Mongolia in 1998?
Offer a terse response. 4.72e+05. What is the difference between the Emissions(kt) of Canada in 1996 and the Emissions(kt) of Solomon Islands in 1998?
Ensure brevity in your answer.  4.79e+05. What is the difference between the Emissions(kt) of Denmark in 1996 and the Emissions(kt) of Mongolia in 1998?
Your answer should be compact. 6.45e+04. What is the difference between the Emissions(kt) of Denmark in 1996 and the Emissions(kt) of Solomon Islands in 1998?
Give a very brief answer. 7.20e+04. What is the difference between the Emissions(kt) of Mongolia in 1996 and the Emissions(kt) of Solomon Islands in 1998?
Offer a terse response. 7880.38. What is the difference between the Emissions(kt) of Canada in 1997 and the Emissions(kt) of Denmark in 1998?
Your response must be concise. 4.35e+05. What is the difference between the Emissions(kt) in Canada in 1997 and the Emissions(kt) in Mongolia in 1998?
Make the answer very short. 4.87e+05. What is the difference between the Emissions(kt) of Canada in 1997 and the Emissions(kt) of Solomon Islands in 1998?
Make the answer very short. 4.94e+05. What is the difference between the Emissions(kt) of Denmark in 1997 and the Emissions(kt) of Mongolia in 1998?
Your response must be concise. 5.38e+04. What is the difference between the Emissions(kt) of Denmark in 1997 and the Emissions(kt) of Solomon Islands in 1998?
Your answer should be compact. 6.14e+04. What is the difference between the Emissions(kt) in Mongolia in 1997 and the Emissions(kt) in Solomon Islands in 1998?
Your answer should be very brief. 7550.35. What is the average Emissions(kt) in Canada per year?
Keep it short and to the point. 4.65e+05. What is the average Emissions(kt) in Denmark per year?
Your response must be concise. 6.04e+04. What is the average Emissions(kt) of Mongolia per year?
Ensure brevity in your answer.  8993.32. What is the average Emissions(kt) of Solomon Islands per year?
Your response must be concise. 159.97. In the year 1991, what is the difference between the Emissions(kt) in Canada and Emissions(kt) in Denmark?
Make the answer very short. 3.67e+05. In the year 1991, what is the difference between the Emissions(kt) in Canada and Emissions(kt) in Mongolia?
Ensure brevity in your answer.  4.15e+05. In the year 1991, what is the difference between the Emissions(kt) of Canada and Emissions(kt) of Solomon Islands?
Keep it short and to the point. 4.27e+05. In the year 1991, what is the difference between the Emissions(kt) of Denmark and Emissions(kt) of Mongolia?
Your answer should be very brief. 4.81e+04. In the year 1991, what is the difference between the Emissions(kt) in Denmark and Emissions(kt) in Solomon Islands?
Provide a succinct answer. 6.01e+04. In the year 1991, what is the difference between the Emissions(kt) of Mongolia and Emissions(kt) of Solomon Islands?
Keep it short and to the point. 1.20e+04. In the year 1992, what is the difference between the Emissions(kt) of Canada and Emissions(kt) of Denmark?
Your answer should be compact. 3.86e+05. In the year 1992, what is the difference between the Emissions(kt) in Canada and Emissions(kt) in Mongolia?
Your answer should be very brief. 4.30e+05. In the year 1992, what is the difference between the Emissions(kt) in Canada and Emissions(kt) in Solomon Islands?
Offer a very short reply. 4.40e+05. In the year 1992, what is the difference between the Emissions(kt) in Denmark and Emissions(kt) in Mongolia?
Make the answer very short. 4.32e+04. In the year 1992, what is the difference between the Emissions(kt) in Denmark and Emissions(kt) in Solomon Islands?
Provide a short and direct response. 5.42e+04. In the year 1992, what is the difference between the Emissions(kt) of Mongolia and Emissions(kt) of Solomon Islands?
Your answer should be very brief. 1.09e+04. In the year 1993, what is the difference between the Emissions(kt) of Canada and Emissions(kt) of Denmark?
Offer a very short reply. 3.89e+05. In the year 1993, what is the difference between the Emissions(kt) of Canada and Emissions(kt) of Mongolia?
Your answer should be very brief. 4.36e+05. In the year 1993, what is the difference between the Emissions(kt) in Canada and Emissions(kt) in Solomon Islands?
Provide a succinct answer. 4.46e+05. In the year 1993, what is the difference between the Emissions(kt) in Denmark and Emissions(kt) in Mongolia?
Keep it short and to the point. 4.78e+04. In the year 1993, what is the difference between the Emissions(kt) in Denmark and Emissions(kt) in Solomon Islands?
Offer a very short reply. 5.69e+04. In the year 1993, what is the difference between the Emissions(kt) of Mongolia and Emissions(kt) of Solomon Islands?
Provide a short and direct response. 9156.5. In the year 1994, what is the difference between the Emissions(kt) of Canada and Emissions(kt) of Denmark?
Make the answer very short. 3.96e+05. In the year 1994, what is the difference between the Emissions(kt) of Canada and Emissions(kt) of Mongolia?
Provide a short and direct response. 4.49e+05. In the year 1994, what is the difference between the Emissions(kt) of Canada and Emissions(kt) of Solomon Islands?
Provide a succinct answer. 4.57e+05. In the year 1994, what is the difference between the Emissions(kt) of Denmark and Emissions(kt) of Mongolia?
Keep it short and to the point. 5.30e+04. In the year 1994, what is the difference between the Emissions(kt) of Denmark and Emissions(kt) of Solomon Islands?
Offer a very short reply. 6.08e+04. In the year 1994, what is the difference between the Emissions(kt) of Mongolia and Emissions(kt) of Solomon Islands?
Give a very brief answer. 7807.04. In the year 1995, what is the difference between the Emissions(kt) in Canada and Emissions(kt) in Denmark?
Give a very brief answer. 4.10e+05. In the year 1995, what is the difference between the Emissions(kt) in Canada and Emissions(kt) in Mongolia?
Provide a succinct answer. 4.60e+05. In the year 1995, what is the difference between the Emissions(kt) in Canada and Emissions(kt) in Solomon Islands?
Give a very brief answer. 4.67e+05. In the year 1995, what is the difference between the Emissions(kt) in Denmark and Emissions(kt) in Mongolia?
Give a very brief answer. 4.92e+04. In the year 1995, what is the difference between the Emissions(kt) of Denmark and Emissions(kt) of Solomon Islands?
Make the answer very short. 5.70e+04. In the year 1995, what is the difference between the Emissions(kt) in Mongolia and Emissions(kt) in Solomon Islands?
Provide a succinct answer. 7763.04. In the year 1996, what is the difference between the Emissions(kt) of Canada and Emissions(kt) of Denmark?
Keep it short and to the point. 4.07e+05. In the year 1996, what is the difference between the Emissions(kt) in Canada and Emissions(kt) in Mongolia?
Your answer should be very brief. 4.71e+05. In the year 1996, what is the difference between the Emissions(kt) of Canada and Emissions(kt) of Solomon Islands?
Your answer should be compact. 4.79e+05. In the year 1996, what is the difference between the Emissions(kt) in Denmark and Emissions(kt) in Mongolia?
Ensure brevity in your answer.  6.41e+04. In the year 1996, what is the difference between the Emissions(kt) in Denmark and Emissions(kt) in Solomon Islands?
Your response must be concise. 7.20e+04. In the year 1996, what is the difference between the Emissions(kt) in Mongolia and Emissions(kt) in Solomon Islands?
Keep it short and to the point. 7880.38. In the year 1997, what is the difference between the Emissions(kt) of Canada and Emissions(kt) of Denmark?
Your response must be concise. 4.33e+05. In the year 1997, what is the difference between the Emissions(kt) of Canada and Emissions(kt) of Mongolia?
Your answer should be compact. 4.87e+05. In the year 1997, what is the difference between the Emissions(kt) in Canada and Emissions(kt) in Solomon Islands?
Your answer should be compact. 4.94e+05. In the year 1997, what is the difference between the Emissions(kt) in Denmark and Emissions(kt) in Mongolia?
Provide a succinct answer. 5.38e+04. In the year 1997, what is the difference between the Emissions(kt) in Denmark and Emissions(kt) in Solomon Islands?
Provide a short and direct response. 6.14e+04. In the year 1997, what is the difference between the Emissions(kt) in Mongolia and Emissions(kt) in Solomon Islands?
Keep it short and to the point. 7550.35. In the year 1998, what is the difference between the Emissions(kt) in Canada and Emissions(kt) in Denmark?
Your response must be concise. 4.47e+05. In the year 1998, what is the difference between the Emissions(kt) of Canada and Emissions(kt) of Mongolia?
Ensure brevity in your answer.  4.99e+05. In the year 1998, what is the difference between the Emissions(kt) of Canada and Emissions(kt) of Solomon Islands?
Your answer should be very brief. 5.06e+05. In the year 1998, what is the difference between the Emissions(kt) of Denmark and Emissions(kt) of Mongolia?
Keep it short and to the point. 5.18e+04. In the year 1998, what is the difference between the Emissions(kt) of Denmark and Emissions(kt) of Solomon Islands?
Keep it short and to the point. 5.94e+04. In the year 1998, what is the difference between the Emissions(kt) in Mongolia and Emissions(kt) in Solomon Islands?
Your answer should be very brief. 7546.69. What is the ratio of the Emissions(kt) of Canada in 1991 to that in 1992?
Your answer should be compact. 0.97. What is the ratio of the Emissions(kt) in Denmark in 1991 to that in 1992?
Your answer should be compact. 1.11. What is the ratio of the Emissions(kt) of Mongolia in 1991 to that in 1992?
Provide a short and direct response. 1.1. What is the ratio of the Emissions(kt) of Canada in 1991 to that in 1993?
Offer a very short reply. 0.96. What is the ratio of the Emissions(kt) of Denmark in 1991 to that in 1993?
Keep it short and to the point. 1.06. What is the ratio of the Emissions(kt) in Mongolia in 1991 to that in 1993?
Give a very brief answer. 1.31. What is the ratio of the Emissions(kt) in Solomon Islands in 1991 to that in 1993?
Keep it short and to the point. 1.02. What is the ratio of the Emissions(kt) in Canada in 1991 to that in 1994?
Offer a very short reply. 0.93. What is the ratio of the Emissions(kt) in Denmark in 1991 to that in 1994?
Provide a short and direct response. 0.99. What is the ratio of the Emissions(kt) of Mongolia in 1991 to that in 1994?
Give a very brief answer. 1.53. What is the ratio of the Emissions(kt) in Solomon Islands in 1991 to that in 1994?
Your answer should be compact. 1.05. What is the ratio of the Emissions(kt) of Canada in 1991 to that in 1995?
Give a very brief answer. 0.91. What is the ratio of the Emissions(kt) of Denmark in 1991 to that in 1995?
Ensure brevity in your answer.  1.05. What is the ratio of the Emissions(kt) of Mongolia in 1991 to that in 1995?
Make the answer very short. 1.54. What is the ratio of the Emissions(kt) in Solomon Islands in 1991 to that in 1995?
Provide a short and direct response. 1. What is the ratio of the Emissions(kt) of Canada in 1991 to that in 1996?
Make the answer very short. 0.89. What is the ratio of the Emissions(kt) in Denmark in 1991 to that in 1996?
Your response must be concise. 0.83. What is the ratio of the Emissions(kt) in Mongolia in 1991 to that in 1996?
Your response must be concise. 1.52. What is the ratio of the Emissions(kt) of Canada in 1991 to that in 1997?
Give a very brief answer. 0.86. What is the ratio of the Emissions(kt) in Denmark in 1991 to that in 1997?
Provide a short and direct response. 0.98. What is the ratio of the Emissions(kt) in Mongolia in 1991 to that in 1997?
Provide a succinct answer. 1.58. What is the ratio of the Emissions(kt) in Solomon Islands in 1991 to that in 1997?
Make the answer very short. 1. What is the ratio of the Emissions(kt) of Canada in 1991 to that in 1998?
Your response must be concise. 0.84. What is the ratio of the Emissions(kt) in Denmark in 1991 to that in 1998?
Make the answer very short. 1.01. What is the ratio of the Emissions(kt) of Mongolia in 1991 to that in 1998?
Offer a very short reply. 1.58. What is the ratio of the Emissions(kt) in Solomon Islands in 1991 to that in 1998?
Offer a terse response. 1. What is the ratio of the Emissions(kt) of Canada in 1992 to that in 1993?
Your answer should be compact. 0.99. What is the ratio of the Emissions(kt) of Denmark in 1992 to that in 1993?
Ensure brevity in your answer.  0.95. What is the ratio of the Emissions(kt) in Mongolia in 1992 to that in 1993?
Offer a terse response. 1.19. What is the ratio of the Emissions(kt) in Solomon Islands in 1992 to that in 1993?
Your answer should be compact. 1.02. What is the ratio of the Emissions(kt) of Canada in 1992 to that in 1994?
Keep it short and to the point. 0.96. What is the ratio of the Emissions(kt) of Denmark in 1992 to that in 1994?
Your answer should be compact. 0.89. What is the ratio of the Emissions(kt) of Mongolia in 1992 to that in 1994?
Make the answer very short. 1.39. What is the ratio of the Emissions(kt) in Solomon Islands in 1992 to that in 1994?
Ensure brevity in your answer.  1.05. What is the ratio of the Emissions(kt) in Canada in 1992 to that in 1995?
Offer a very short reply. 0.94. What is the ratio of the Emissions(kt) in Denmark in 1992 to that in 1995?
Make the answer very short. 0.95. What is the ratio of the Emissions(kt) in Mongolia in 1992 to that in 1995?
Give a very brief answer. 1.4. What is the ratio of the Emissions(kt) of Solomon Islands in 1992 to that in 1995?
Ensure brevity in your answer.  1. What is the ratio of the Emissions(kt) in Canada in 1992 to that in 1996?
Your response must be concise. 0.92. What is the ratio of the Emissions(kt) of Denmark in 1992 to that in 1996?
Your answer should be very brief. 0.75. What is the ratio of the Emissions(kt) of Mongolia in 1992 to that in 1996?
Ensure brevity in your answer.  1.38. What is the ratio of the Emissions(kt) in Solomon Islands in 1992 to that in 1996?
Ensure brevity in your answer.  1. What is the ratio of the Emissions(kt) of Canada in 1992 to that in 1997?
Keep it short and to the point. 0.89. What is the ratio of the Emissions(kt) in Denmark in 1992 to that in 1997?
Your answer should be very brief. 0.88. What is the ratio of the Emissions(kt) of Mongolia in 1992 to that in 1997?
Your response must be concise. 1.44. What is the ratio of the Emissions(kt) of Solomon Islands in 1992 to that in 1997?
Your answer should be compact. 1. What is the ratio of the Emissions(kt) in Canada in 1992 to that in 1998?
Your response must be concise. 0.87. What is the ratio of the Emissions(kt) in Denmark in 1992 to that in 1998?
Offer a very short reply. 0.91. What is the ratio of the Emissions(kt) of Mongolia in 1992 to that in 1998?
Offer a terse response. 1.44. What is the ratio of the Emissions(kt) of Solomon Islands in 1992 to that in 1998?
Provide a succinct answer. 1. What is the ratio of the Emissions(kt) of Canada in 1993 to that in 1994?
Make the answer very short. 0.98. What is the ratio of the Emissions(kt) in Denmark in 1993 to that in 1994?
Provide a short and direct response. 0.94. What is the ratio of the Emissions(kt) of Mongolia in 1993 to that in 1994?
Make the answer very short. 1.17. What is the ratio of the Emissions(kt) of Solomon Islands in 1993 to that in 1994?
Offer a terse response. 1.02. What is the ratio of the Emissions(kt) in Canada in 1993 to that in 1995?
Your answer should be very brief. 0.95. What is the ratio of the Emissions(kt) in Mongolia in 1993 to that in 1995?
Provide a succinct answer. 1.18. What is the ratio of the Emissions(kt) in Solomon Islands in 1993 to that in 1995?
Offer a terse response. 0.98. What is the ratio of the Emissions(kt) in Canada in 1993 to that in 1996?
Give a very brief answer. 0.93. What is the ratio of the Emissions(kt) in Denmark in 1993 to that in 1996?
Your answer should be very brief. 0.79. What is the ratio of the Emissions(kt) of Mongolia in 1993 to that in 1996?
Your answer should be very brief. 1.16. What is the ratio of the Emissions(kt) in Solomon Islands in 1993 to that in 1996?
Offer a terse response. 0.98. What is the ratio of the Emissions(kt) of Canada in 1993 to that in 1997?
Keep it short and to the point. 0.9. What is the ratio of the Emissions(kt) in Denmark in 1993 to that in 1997?
Keep it short and to the point. 0.93. What is the ratio of the Emissions(kt) of Mongolia in 1993 to that in 1997?
Provide a succinct answer. 1.21. What is the ratio of the Emissions(kt) in Solomon Islands in 1993 to that in 1997?
Provide a succinct answer. 0.98. What is the ratio of the Emissions(kt) in Mongolia in 1993 to that in 1998?
Your answer should be very brief. 1.21. What is the ratio of the Emissions(kt) in Solomon Islands in 1993 to that in 1998?
Give a very brief answer. 0.98. What is the ratio of the Emissions(kt) in Canada in 1994 to that in 1995?
Keep it short and to the point. 0.98. What is the ratio of the Emissions(kt) of Denmark in 1994 to that in 1995?
Keep it short and to the point. 1.07. What is the ratio of the Emissions(kt) in Mongolia in 1994 to that in 1995?
Provide a succinct answer. 1. What is the ratio of the Emissions(kt) in Solomon Islands in 1994 to that in 1995?
Make the answer very short. 0.95. What is the ratio of the Emissions(kt) of Canada in 1994 to that in 1996?
Your answer should be compact. 0.95. What is the ratio of the Emissions(kt) in Denmark in 1994 to that in 1996?
Keep it short and to the point. 0.85. What is the ratio of the Emissions(kt) in Solomon Islands in 1994 to that in 1996?
Your answer should be very brief. 0.95. What is the ratio of the Emissions(kt) of Canada in 1994 to that in 1997?
Offer a terse response. 0.92. What is the ratio of the Emissions(kt) of Denmark in 1994 to that in 1997?
Keep it short and to the point. 0.99. What is the ratio of the Emissions(kt) in Mongolia in 1994 to that in 1997?
Ensure brevity in your answer.  1.03. What is the ratio of the Emissions(kt) in Solomon Islands in 1994 to that in 1997?
Provide a succinct answer. 0.95. What is the ratio of the Emissions(kt) of Canada in 1994 to that in 1998?
Your answer should be compact. 0.9. What is the ratio of the Emissions(kt) of Denmark in 1994 to that in 1998?
Keep it short and to the point. 1.02. What is the ratio of the Emissions(kt) of Mongolia in 1994 to that in 1998?
Ensure brevity in your answer.  1.03. What is the ratio of the Emissions(kt) in Solomon Islands in 1994 to that in 1998?
Provide a short and direct response. 0.95. What is the ratio of the Emissions(kt) of Canada in 1995 to that in 1996?
Offer a terse response. 0.98. What is the ratio of the Emissions(kt) of Denmark in 1995 to that in 1996?
Your answer should be very brief. 0.79. What is the ratio of the Emissions(kt) of Mongolia in 1995 to that in 1996?
Offer a terse response. 0.99. What is the ratio of the Emissions(kt) in Canada in 1995 to that in 1997?
Your response must be concise. 0.95. What is the ratio of the Emissions(kt) of Denmark in 1995 to that in 1997?
Provide a succinct answer. 0.93. What is the ratio of the Emissions(kt) in Mongolia in 1995 to that in 1997?
Your answer should be very brief. 1.03. What is the ratio of the Emissions(kt) in Solomon Islands in 1995 to that in 1997?
Make the answer very short. 1. What is the ratio of the Emissions(kt) of Canada in 1995 to that in 1998?
Provide a short and direct response. 0.92. What is the ratio of the Emissions(kt) in Denmark in 1995 to that in 1998?
Your answer should be compact. 0.96. What is the ratio of the Emissions(kt) of Mongolia in 1995 to that in 1998?
Your answer should be compact. 1.03. What is the ratio of the Emissions(kt) of Solomon Islands in 1995 to that in 1998?
Make the answer very short. 1. What is the ratio of the Emissions(kt) in Canada in 1996 to that in 1997?
Make the answer very short. 0.97. What is the ratio of the Emissions(kt) of Denmark in 1996 to that in 1997?
Your response must be concise. 1.17. What is the ratio of the Emissions(kt) in Mongolia in 1996 to that in 1997?
Ensure brevity in your answer.  1.04. What is the ratio of the Emissions(kt) of Solomon Islands in 1996 to that in 1997?
Your answer should be very brief. 1. What is the ratio of the Emissions(kt) of Canada in 1996 to that in 1998?
Ensure brevity in your answer.  0.95. What is the ratio of the Emissions(kt) of Denmark in 1996 to that in 1998?
Provide a short and direct response. 1.21. What is the ratio of the Emissions(kt) of Mongolia in 1996 to that in 1998?
Make the answer very short. 1.04. What is the ratio of the Emissions(kt) of Solomon Islands in 1996 to that in 1998?
Keep it short and to the point. 1. What is the ratio of the Emissions(kt) of Canada in 1997 to that in 1998?
Your answer should be very brief. 0.98. What is the ratio of the Emissions(kt) of Denmark in 1997 to that in 1998?
Offer a terse response. 1.03. What is the difference between the highest and the second highest Emissions(kt) of Canada?
Your answer should be compact. 1.19e+04. What is the difference between the highest and the second highest Emissions(kt) of Denmark?
Ensure brevity in your answer.  1.06e+04. What is the difference between the highest and the second highest Emissions(kt) in Mongolia?
Ensure brevity in your answer.  1129.44. What is the difference between the highest and the lowest Emissions(kt) of Canada?
Your answer should be very brief. 7.97e+04. What is the difference between the highest and the lowest Emissions(kt) of Denmark?
Your answer should be very brief. 1.79e+04. What is the difference between the highest and the lowest Emissions(kt) of Mongolia?
Your response must be concise. 4499.41. What is the difference between the highest and the lowest Emissions(kt) in Solomon Islands?
Provide a succinct answer. 7.33. 